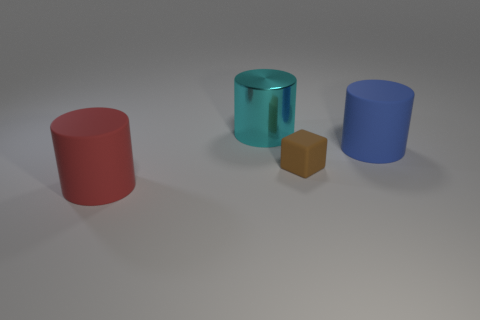Is there any other thing that has the same size as the brown matte object?
Your response must be concise. No. Are there any other things that have the same material as the large cyan thing?
Your answer should be compact. No. Are there any other things that are the same color as the small rubber block?
Give a very brief answer. No. There is a brown object to the right of the cylinder that is to the left of the big cyan metal cylinder; what is it made of?
Provide a succinct answer. Rubber. Is there a brown cylinder made of the same material as the brown thing?
Offer a terse response. No. Do the block and the large object that is in front of the brown matte block have the same material?
Offer a very short reply. Yes. What color is the other metallic cylinder that is the same size as the red cylinder?
Ensure brevity in your answer.  Cyan. There is a rubber cylinder that is on the left side of the big matte cylinder behind the big red rubber thing; how big is it?
Offer a very short reply. Large. Does the metal thing have the same color as the big cylinder that is in front of the blue rubber object?
Give a very brief answer. No. Is the number of big cyan shiny cylinders that are in front of the big cyan cylinder less than the number of large purple things?
Provide a succinct answer. No. 